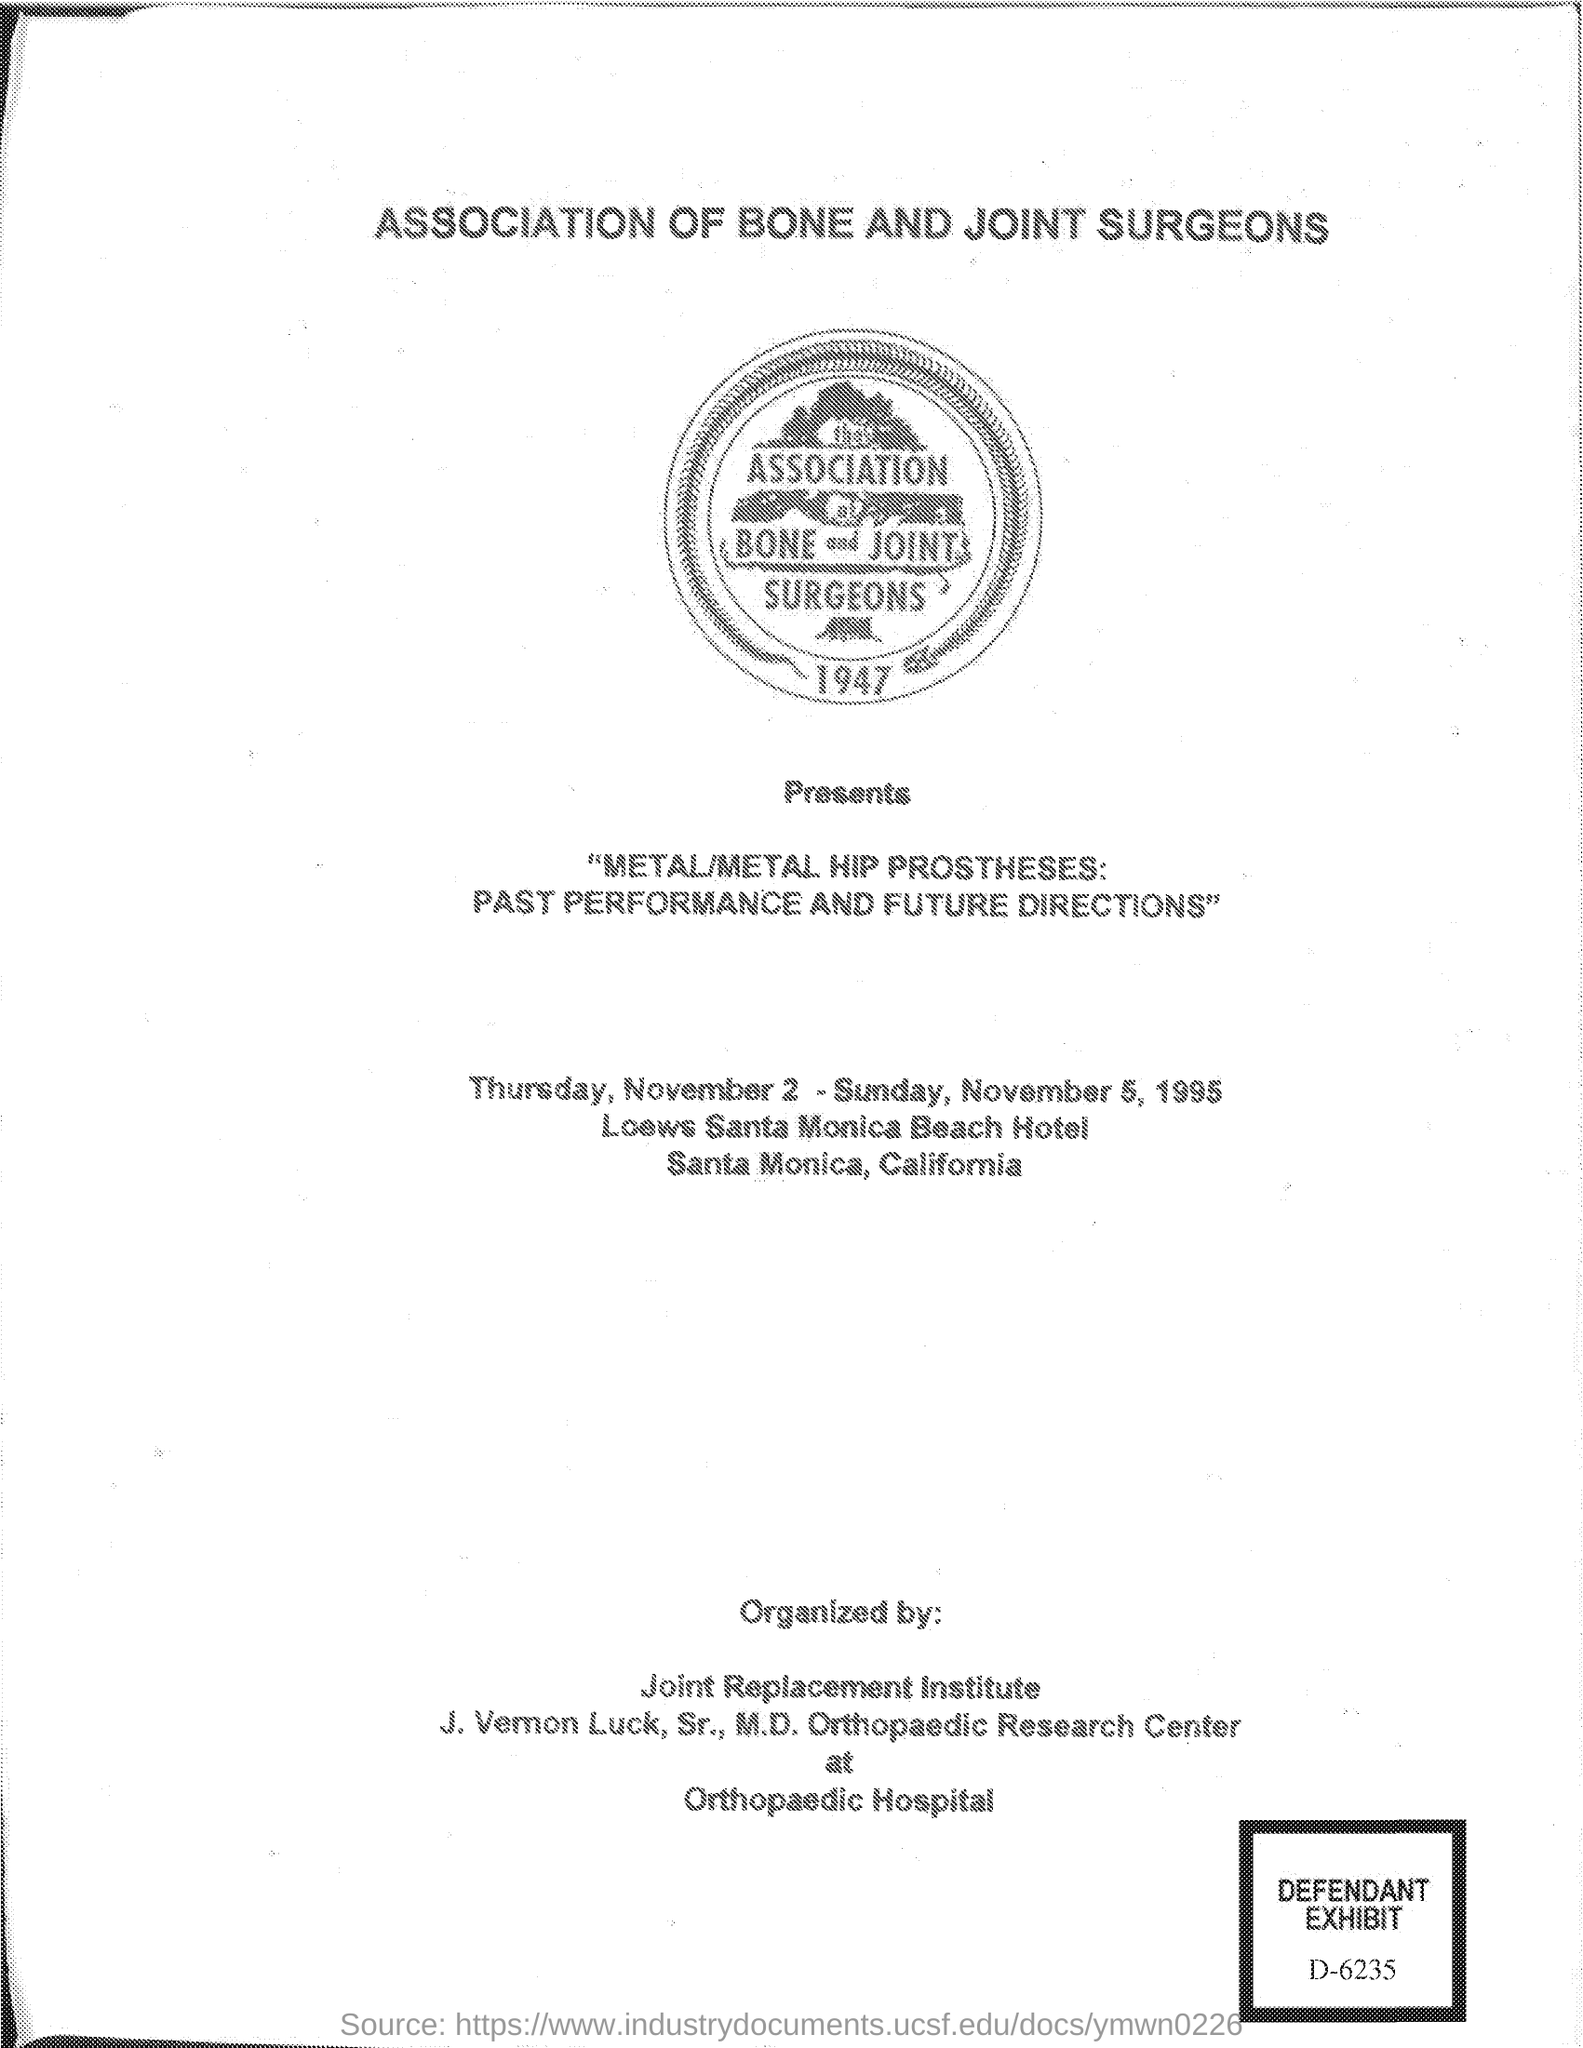Indicate a few pertinent items in this graphic. The association is held in the state of California. The association was held from Thursday, November 2, to Sunday, November 5, 1995. 